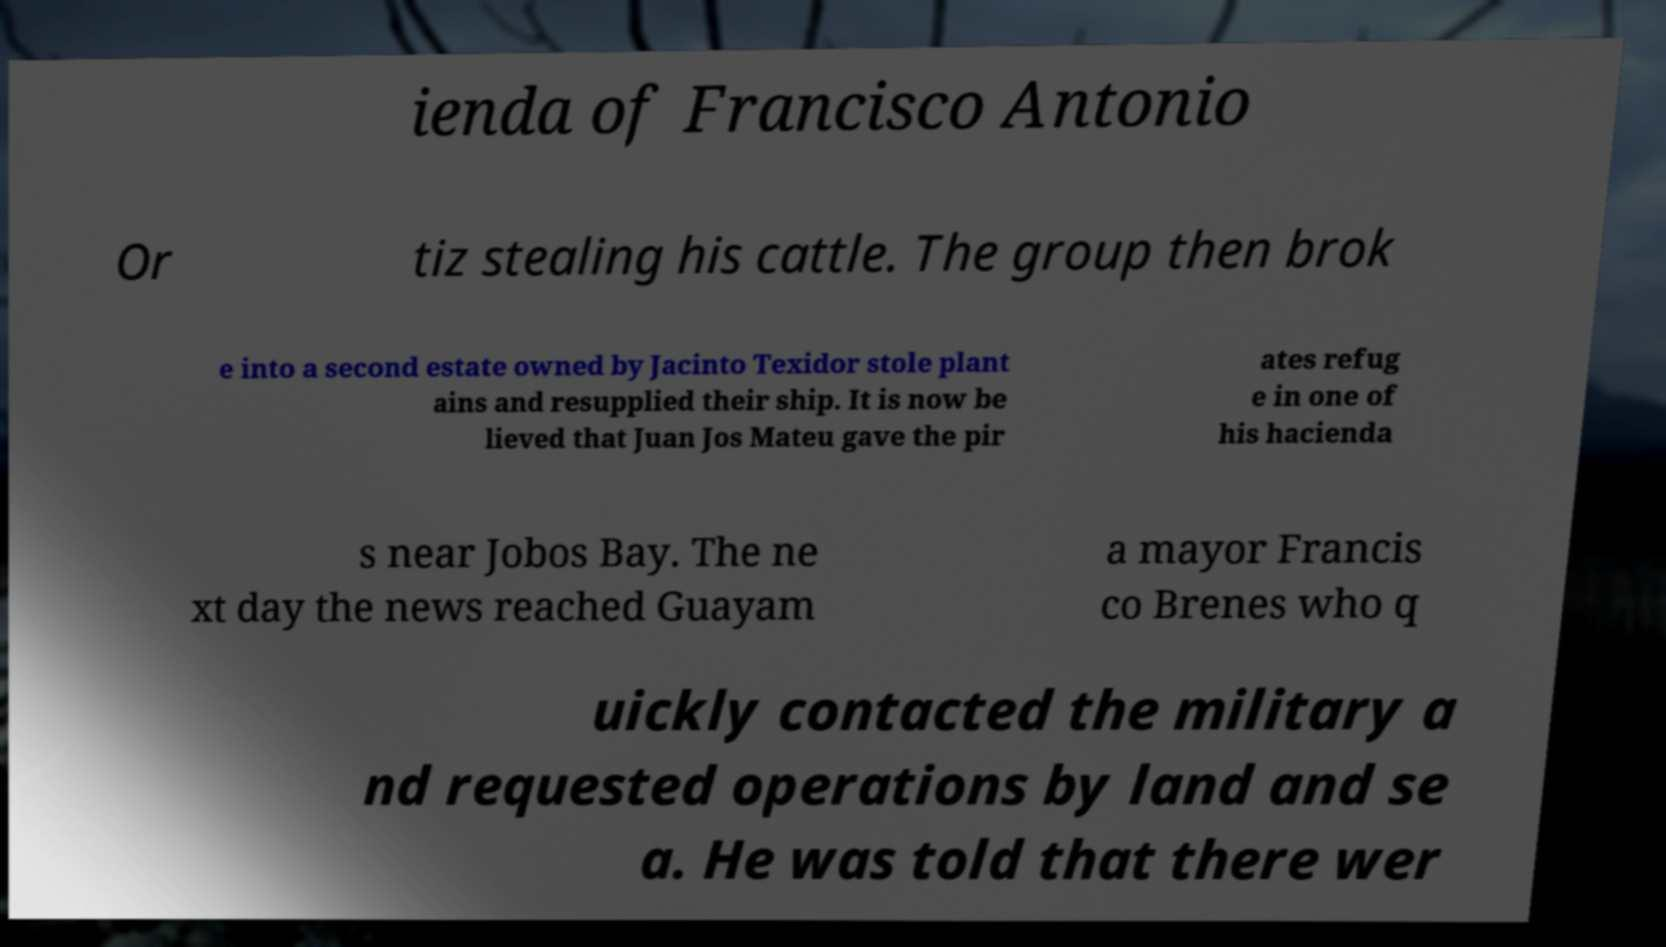Please identify and transcribe the text found in this image. ienda of Francisco Antonio Or tiz stealing his cattle. The group then brok e into a second estate owned by Jacinto Texidor stole plant ains and resupplied their ship. It is now be lieved that Juan Jos Mateu gave the pir ates refug e in one of his hacienda s near Jobos Bay. The ne xt day the news reached Guayam a mayor Francis co Brenes who q uickly contacted the military a nd requested operations by land and se a. He was told that there wer 